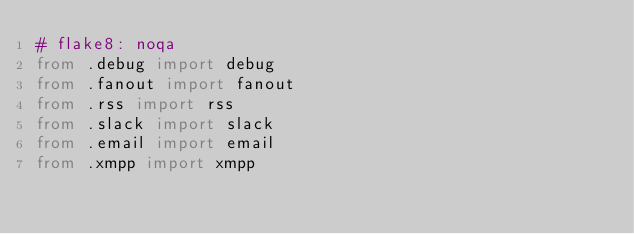Convert code to text. <code><loc_0><loc_0><loc_500><loc_500><_Python_># flake8: noqa
from .debug import debug
from .fanout import fanout
from .rss import rss
from .slack import slack
from .email import email
from .xmpp import xmpp
</code> 